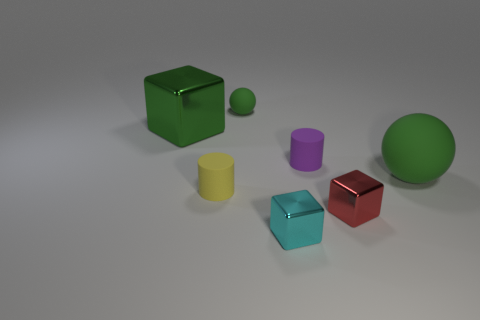Add 1 yellow rubber objects. How many objects exist? 8 Subtract all large blocks. How many blocks are left? 2 Subtract all cylinders. How many objects are left? 5 Subtract 1 cylinders. How many cylinders are left? 1 Subtract all gray spheres. Subtract all gray cubes. How many spheres are left? 2 Subtract all gray spheres. How many yellow cylinders are left? 1 Subtract all purple cylinders. Subtract all cylinders. How many objects are left? 4 Add 7 small green matte objects. How many small green matte objects are left? 8 Add 5 large blocks. How many large blocks exist? 6 Subtract all yellow cylinders. How many cylinders are left? 1 